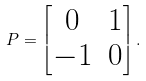Convert formula to latex. <formula><loc_0><loc_0><loc_500><loc_500>P = \begin{bmatrix} 0 & 1 \\ - 1 & 0 \end{bmatrix} .</formula> 